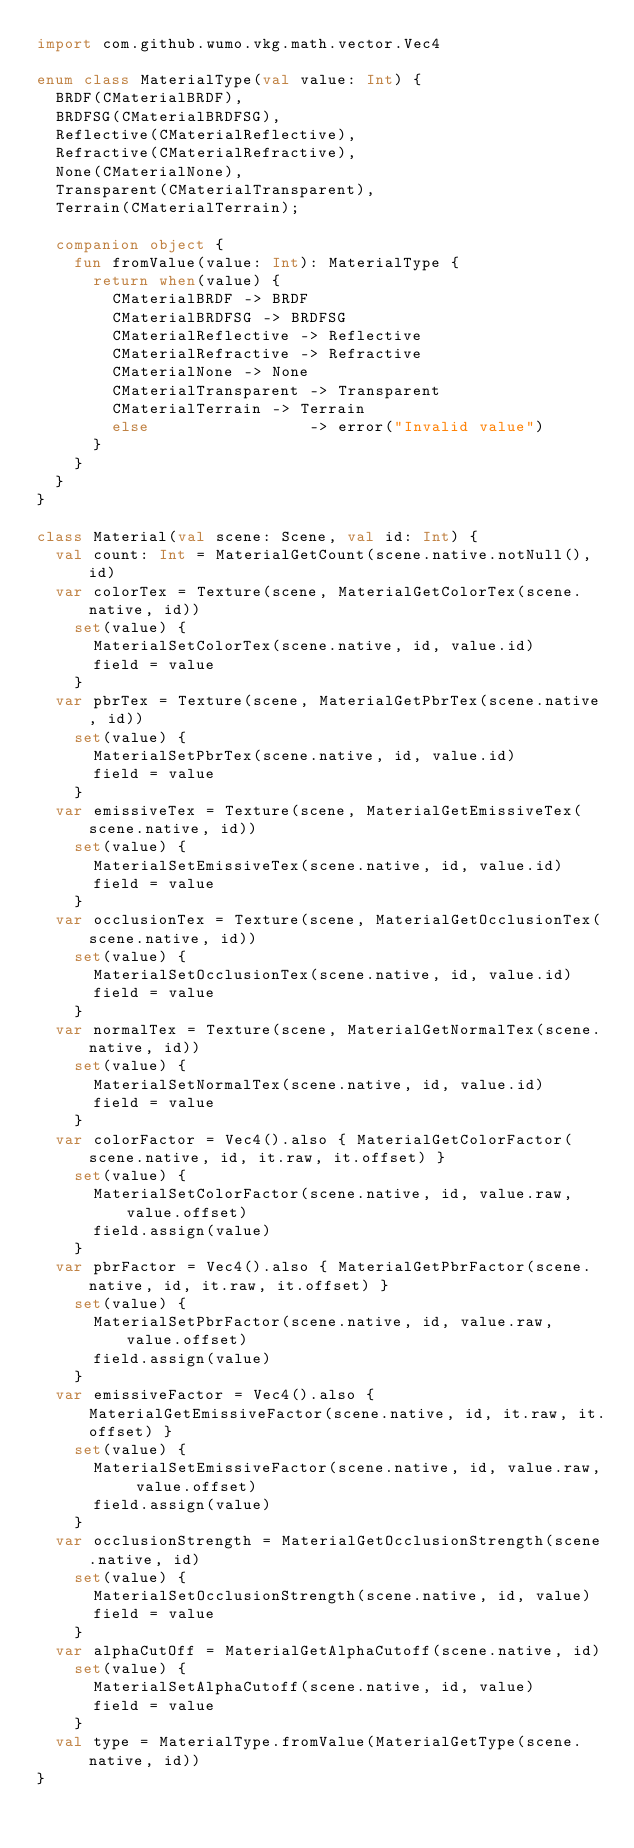Convert code to text. <code><loc_0><loc_0><loc_500><loc_500><_Kotlin_>import com.github.wumo.vkg.math.vector.Vec4

enum class MaterialType(val value: Int) {
  BRDF(CMaterialBRDF),
  BRDFSG(CMaterialBRDFSG),
  Reflective(CMaterialReflective),
  Refractive(CMaterialRefractive),
  None(CMaterialNone),
  Transparent(CMaterialTransparent),
  Terrain(CMaterialTerrain);
  
  companion object {
    fun fromValue(value: Int): MaterialType {
      return when(value) {
        CMaterialBRDF -> BRDF
        CMaterialBRDFSG -> BRDFSG
        CMaterialReflective -> Reflective
        CMaterialRefractive -> Refractive
        CMaterialNone -> None
        CMaterialTransparent -> Transparent
        CMaterialTerrain -> Terrain
        else                 -> error("Invalid value")
      }
    }
  }
}

class Material(val scene: Scene, val id: Int) {
  val count: Int = MaterialGetCount(scene.native.notNull(), id)
  var colorTex = Texture(scene, MaterialGetColorTex(scene.native, id))
    set(value) {
      MaterialSetColorTex(scene.native, id, value.id)
      field = value
    }
  var pbrTex = Texture(scene, MaterialGetPbrTex(scene.native, id))
    set(value) {
      MaterialSetPbrTex(scene.native, id, value.id)
      field = value
    }
  var emissiveTex = Texture(scene, MaterialGetEmissiveTex(scene.native, id))
    set(value) {
      MaterialSetEmissiveTex(scene.native, id, value.id)
      field = value
    }
  var occlusionTex = Texture(scene, MaterialGetOcclusionTex(scene.native, id))
    set(value) {
      MaterialSetOcclusionTex(scene.native, id, value.id)
      field = value
    }
  var normalTex = Texture(scene, MaterialGetNormalTex(scene.native, id))
    set(value) {
      MaterialSetNormalTex(scene.native, id, value.id)
      field = value
    }
  var colorFactor = Vec4().also { MaterialGetColorFactor(scene.native, id, it.raw, it.offset) }
    set(value) {
      MaterialSetColorFactor(scene.native, id, value.raw, value.offset)
      field.assign(value)
    }
  var pbrFactor = Vec4().also { MaterialGetPbrFactor(scene.native, id, it.raw, it.offset) }
    set(value) {
      MaterialSetPbrFactor(scene.native, id, value.raw, value.offset)
      field.assign(value)
    }
  var emissiveFactor = Vec4().also { MaterialGetEmissiveFactor(scene.native, id, it.raw, it.offset) }
    set(value) {
      MaterialSetEmissiveFactor(scene.native, id, value.raw, value.offset)
      field.assign(value)
    }
  var occlusionStrength = MaterialGetOcclusionStrength(scene.native, id)
    set(value) {
      MaterialSetOcclusionStrength(scene.native, id, value)
      field = value
    }
  var alphaCutOff = MaterialGetAlphaCutoff(scene.native, id)
    set(value) {
      MaterialSetAlphaCutoff(scene.native, id, value)
      field = value
    }
  val type = MaterialType.fromValue(MaterialGetType(scene.native, id))
}</code> 